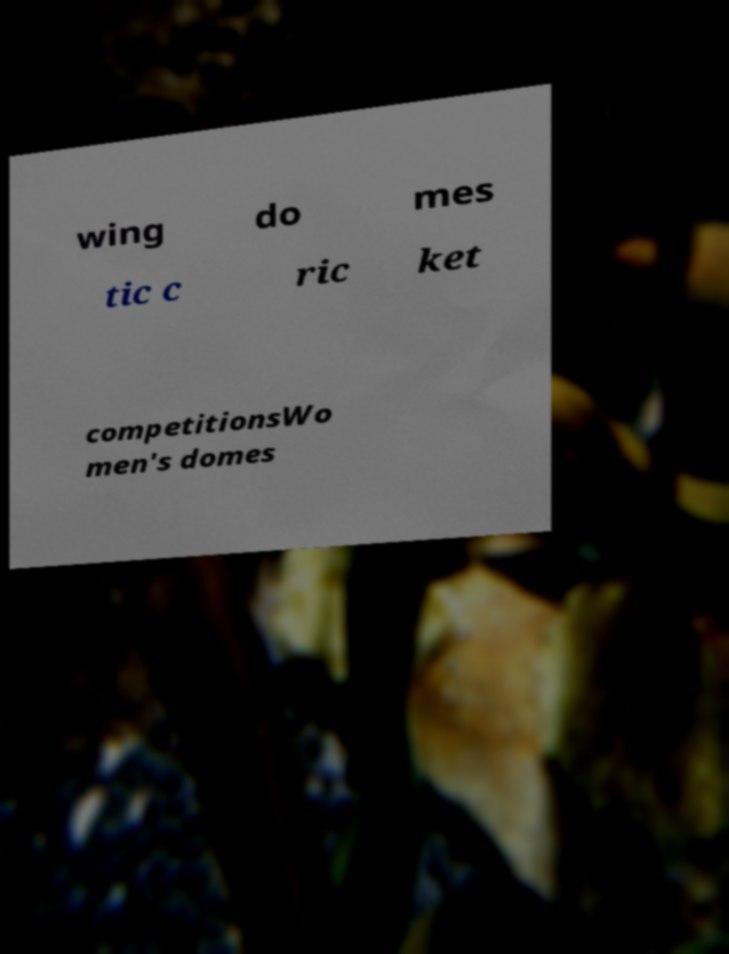Could you assist in decoding the text presented in this image and type it out clearly? wing do mes tic c ric ket competitionsWo men's domes 